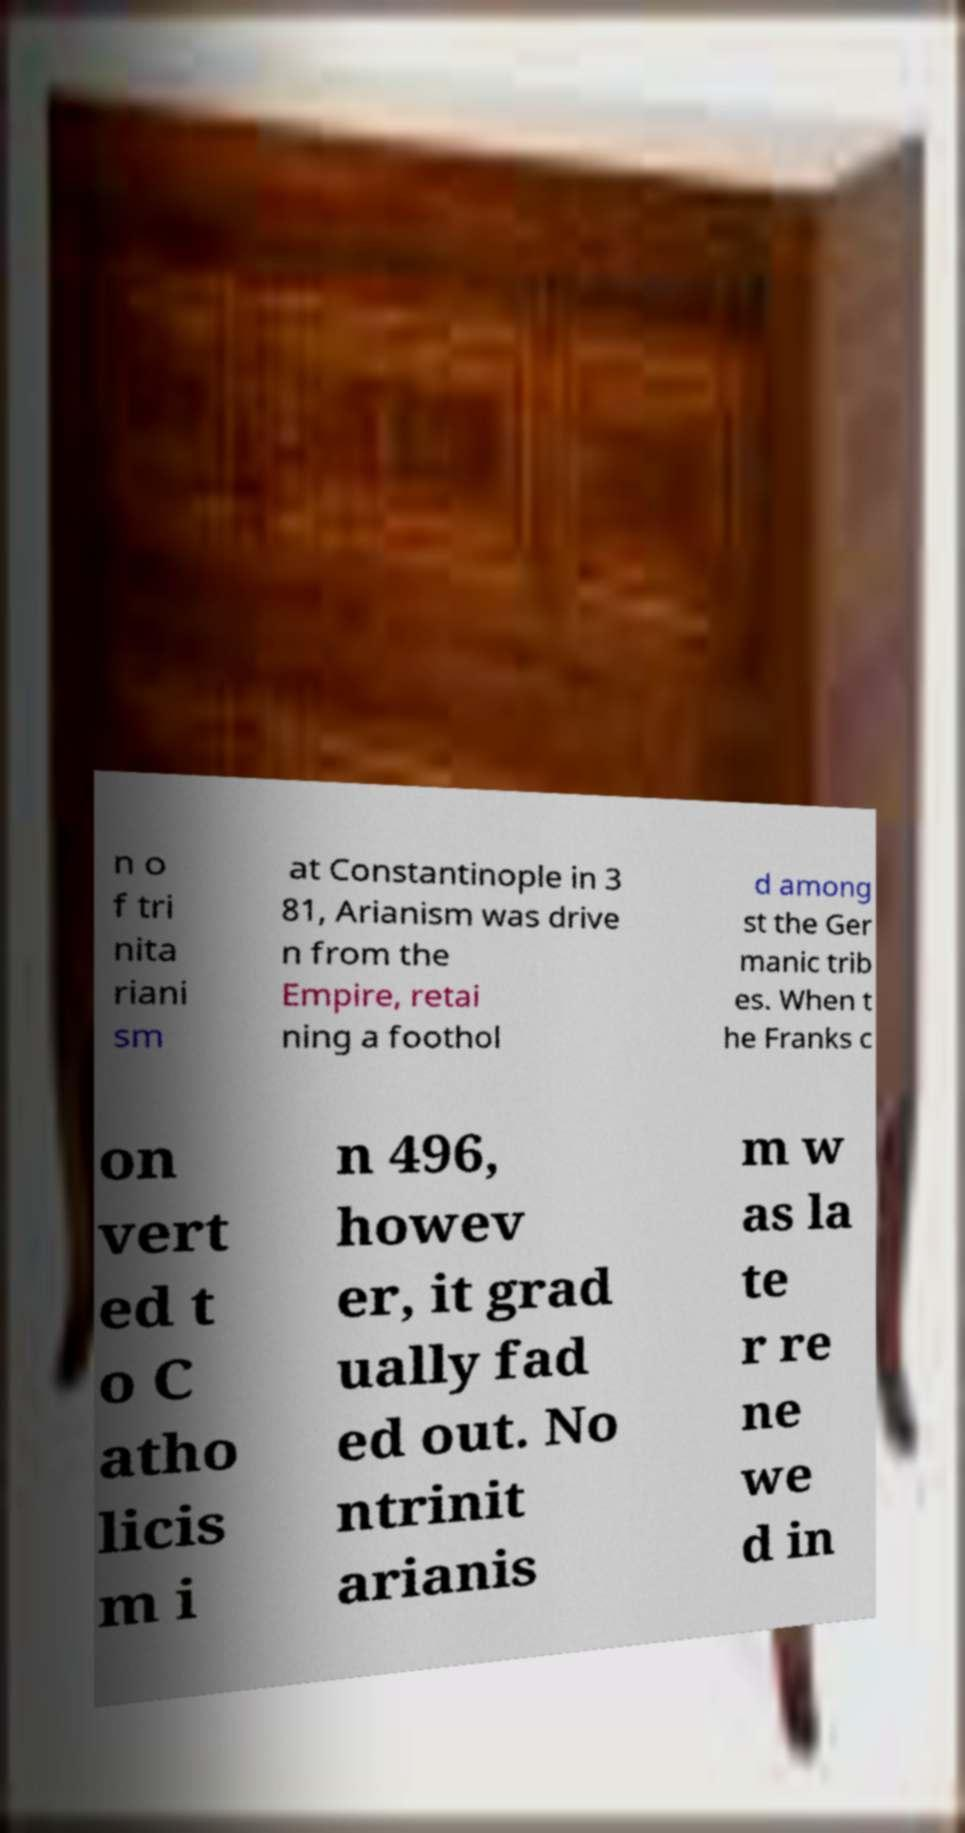What messages or text are displayed in this image? I need them in a readable, typed format. n o f tri nita riani sm at Constantinople in 3 81, Arianism was drive n from the Empire, retai ning a foothol d among st the Ger manic trib es. When t he Franks c on vert ed t o C atho licis m i n 496, howev er, it grad ually fad ed out. No ntrinit arianis m w as la te r re ne we d in 